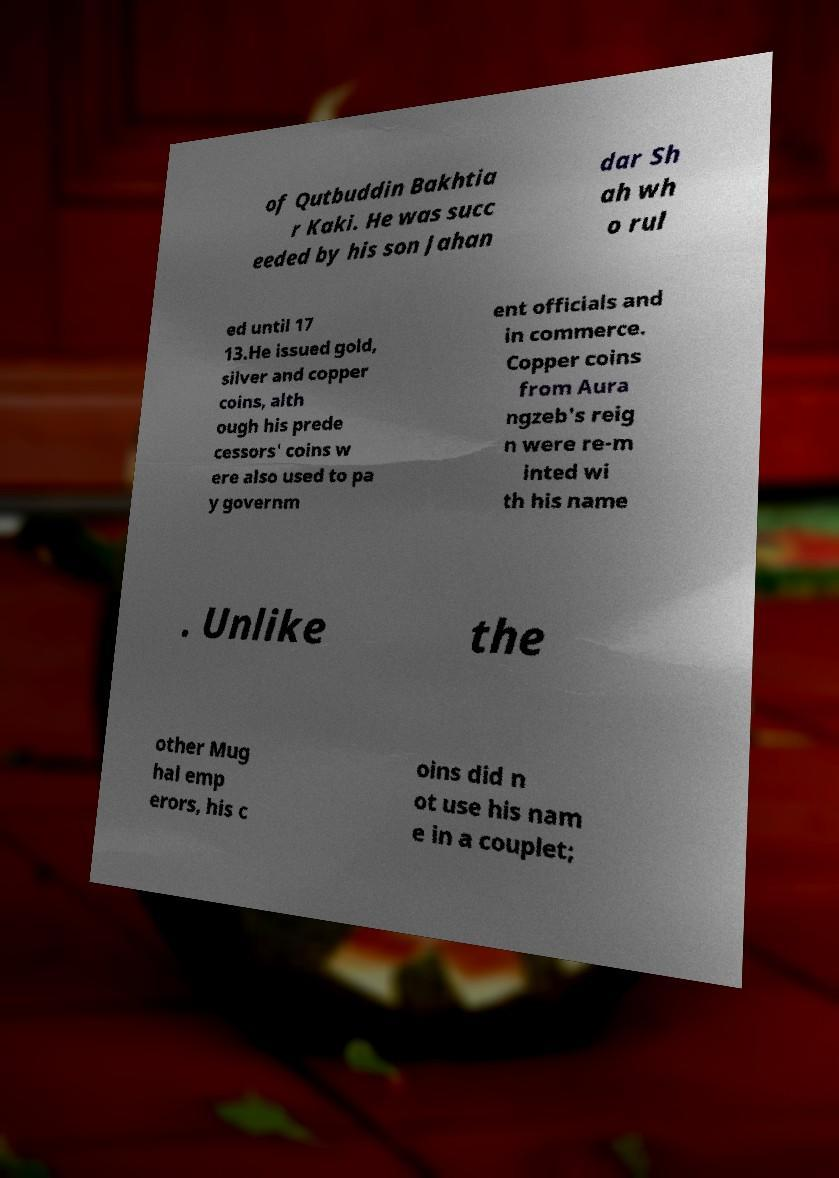I need the written content from this picture converted into text. Can you do that? of Qutbuddin Bakhtia r Kaki. He was succ eeded by his son Jahan dar Sh ah wh o rul ed until 17 13.He issued gold, silver and copper coins, alth ough his prede cessors' coins w ere also used to pa y governm ent officials and in commerce. Copper coins from Aura ngzeb's reig n were re-m inted wi th his name . Unlike the other Mug hal emp erors, his c oins did n ot use his nam e in a couplet; 